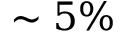<formula> <loc_0><loc_0><loc_500><loc_500>\sim 5 \%</formula> 